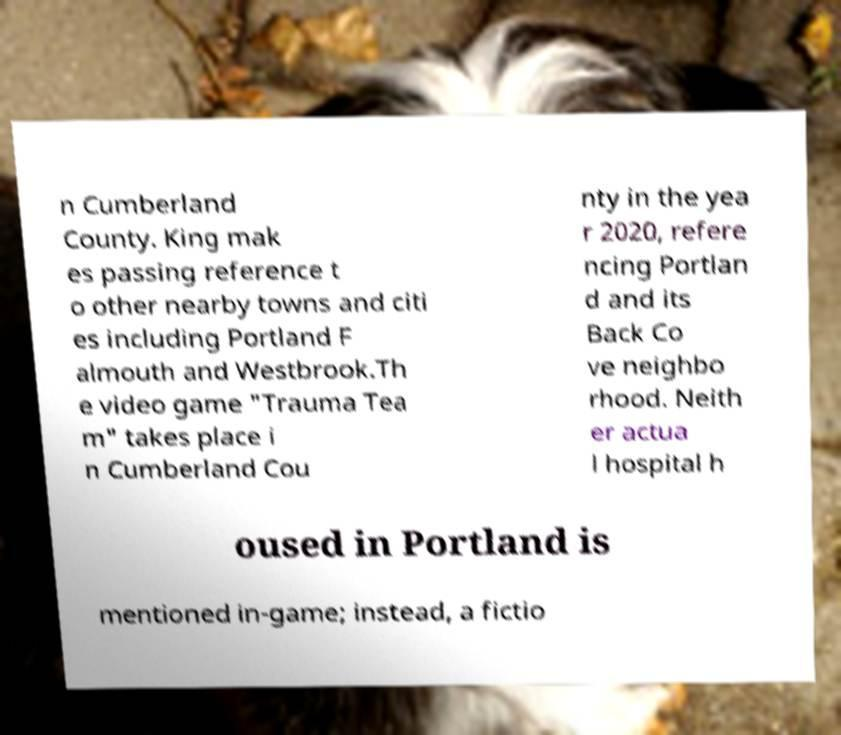Please read and relay the text visible in this image. What does it say? n Cumberland County. King mak es passing reference t o other nearby towns and citi es including Portland F almouth and Westbrook.Th e video game "Trauma Tea m" takes place i n Cumberland Cou nty in the yea r 2020, refere ncing Portlan d and its Back Co ve neighbo rhood. Neith er actua l hospital h oused in Portland is mentioned in-game; instead, a fictio 